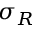<formula> <loc_0><loc_0><loc_500><loc_500>\sigma _ { R }</formula> 